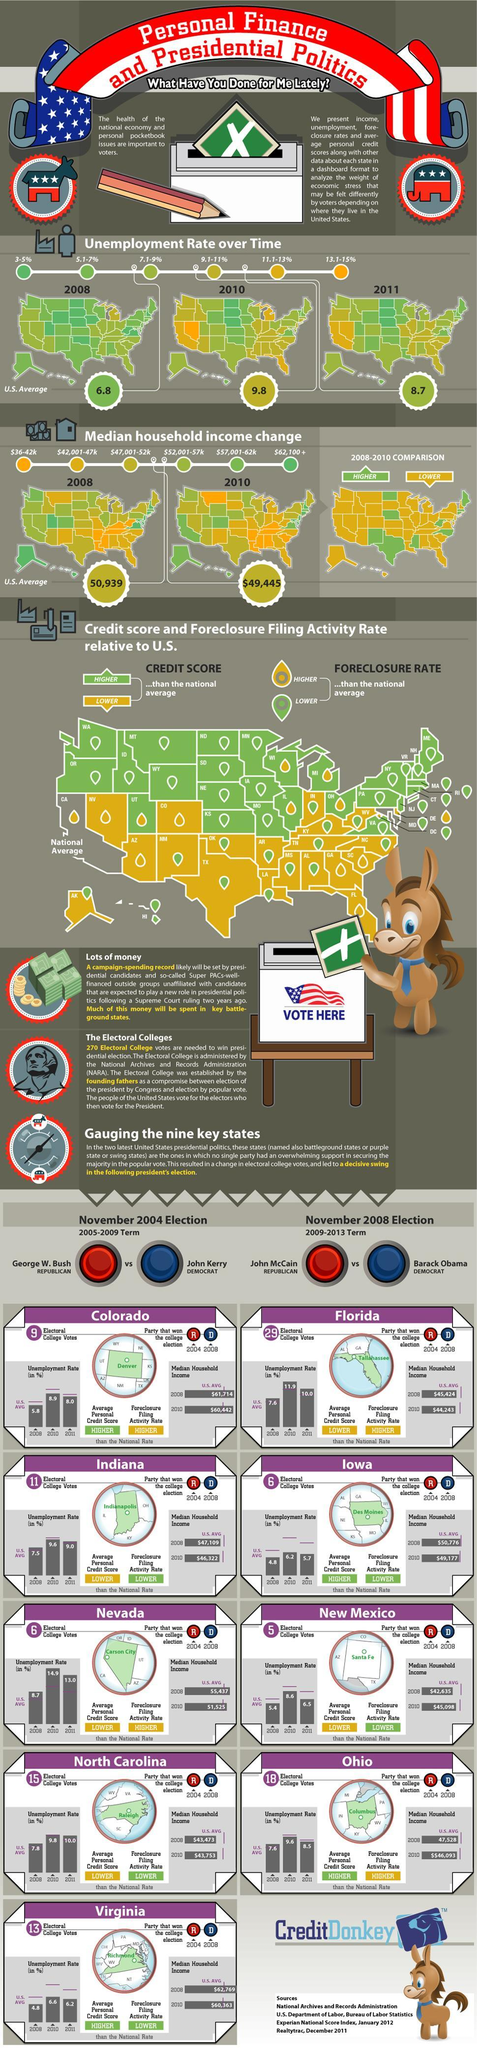How many sources are listed at the bottom?
Answer the question with a short phrase. 4 